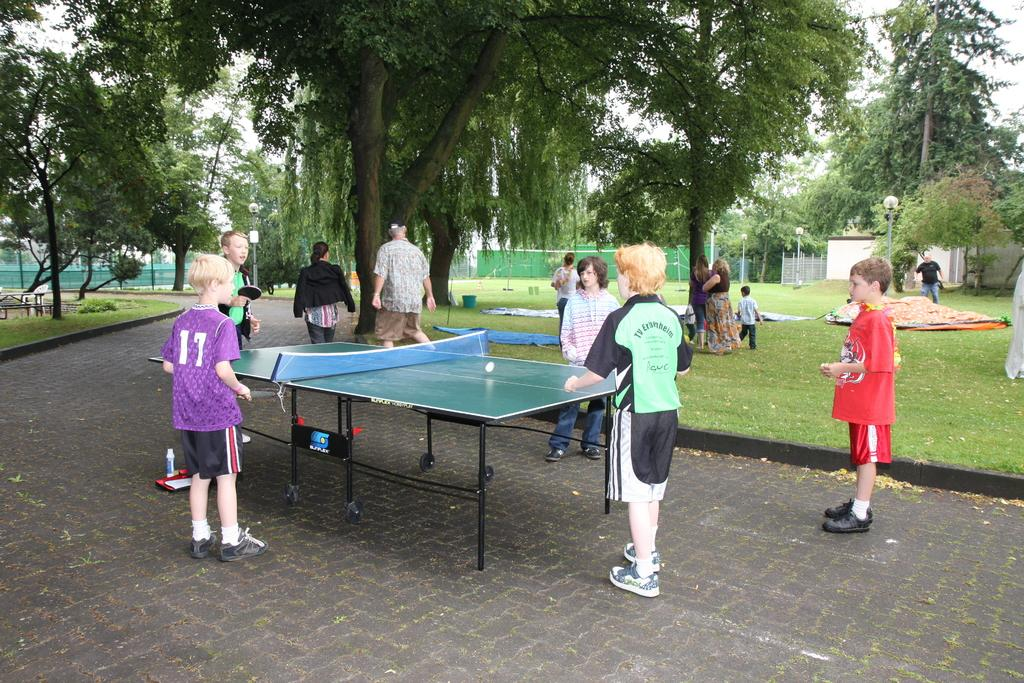How many people are in the image? There is a group of persons in the image, but the exact number is not specified. What are the persons in the image doing? The persons are standing and playing in the image. What is the surface they are standing on? There is grass in the image, which suggests they are standing on a grassy area. Are there any other objects or structures in the image? Yes, there is a table in the image. What can be seen in the background of the image? There are trees in the image, which suggests a natural setting. What type of bubble can be seen floating in the image? There is no bubble present in the image. What do the persons in the image believe about the road? There is no road present in the image, and therefore no belief about a road can be determined. 